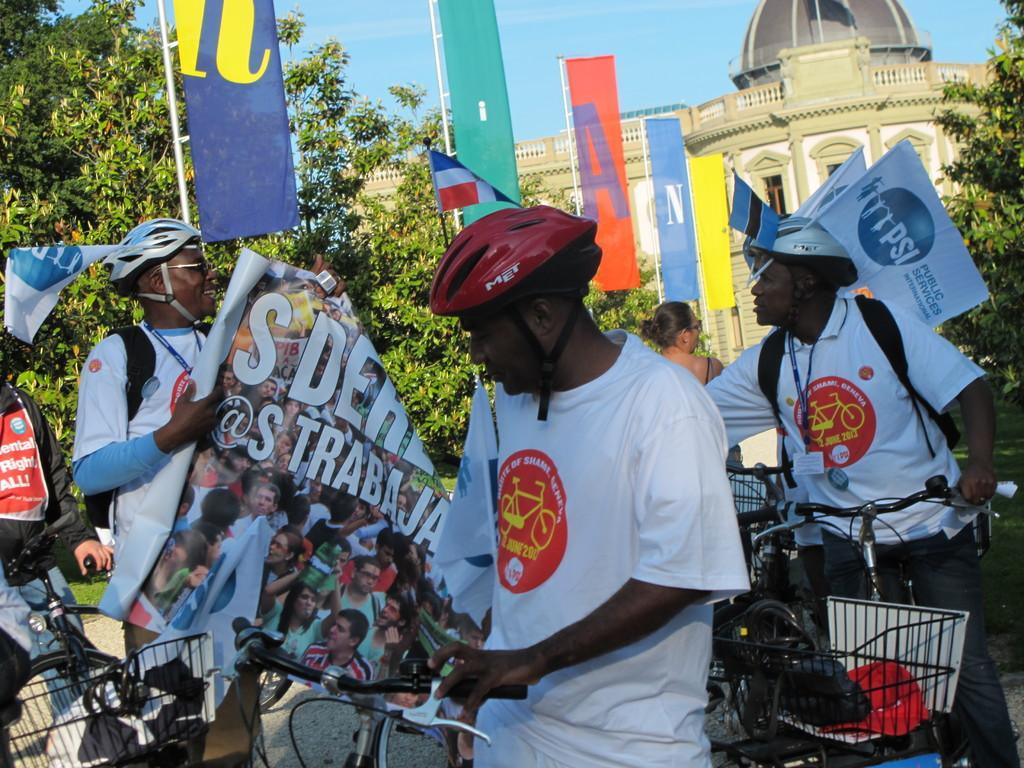Can you describe this image briefly? In this image there are people wearing helmets and holding cycles and one man is holding a banner, on that banner there is some text, in the background there are flags, trees, palace and the sky. 